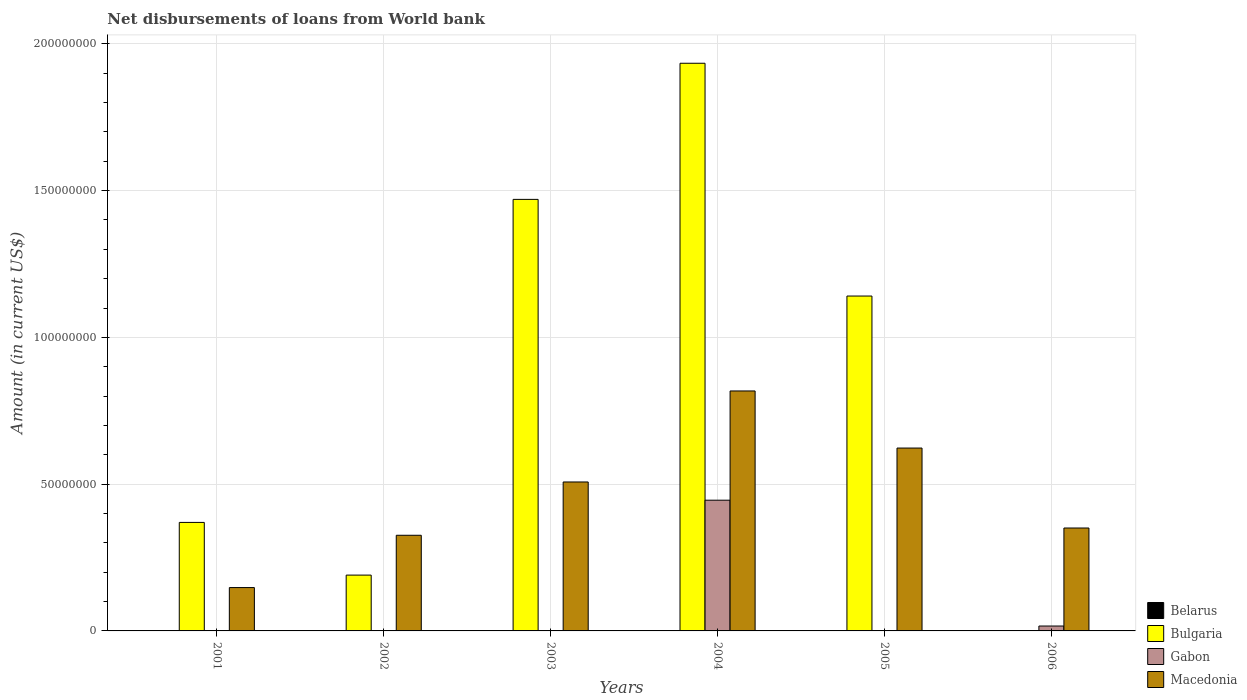How many different coloured bars are there?
Offer a very short reply. 3. How many groups of bars are there?
Your answer should be very brief. 6. Are the number of bars per tick equal to the number of legend labels?
Provide a succinct answer. No. How many bars are there on the 1st tick from the right?
Offer a terse response. 2. What is the label of the 2nd group of bars from the left?
Your answer should be very brief. 2002. In how many cases, is the number of bars for a given year not equal to the number of legend labels?
Offer a terse response. 6. What is the amount of loan disbursed from World Bank in Gabon in 2001?
Your answer should be compact. 0. Across all years, what is the maximum amount of loan disbursed from World Bank in Macedonia?
Provide a short and direct response. 8.18e+07. In which year was the amount of loan disbursed from World Bank in Macedonia maximum?
Offer a terse response. 2004. What is the total amount of loan disbursed from World Bank in Macedonia in the graph?
Provide a short and direct response. 2.77e+08. What is the difference between the amount of loan disbursed from World Bank in Bulgaria in 2002 and that in 2003?
Your answer should be compact. -1.28e+08. What is the difference between the amount of loan disbursed from World Bank in Macedonia in 2003 and the amount of loan disbursed from World Bank in Belarus in 2006?
Your answer should be compact. 5.07e+07. What is the average amount of loan disbursed from World Bank in Gabon per year?
Provide a short and direct response. 7.70e+06. In the year 2004, what is the difference between the amount of loan disbursed from World Bank in Bulgaria and amount of loan disbursed from World Bank in Macedonia?
Offer a very short reply. 1.12e+08. What is the ratio of the amount of loan disbursed from World Bank in Bulgaria in 2001 to that in 2002?
Keep it short and to the point. 1.94. What is the difference between the highest and the second highest amount of loan disbursed from World Bank in Bulgaria?
Provide a succinct answer. 4.64e+07. What is the difference between the highest and the lowest amount of loan disbursed from World Bank in Macedonia?
Give a very brief answer. 6.70e+07. In how many years, is the amount of loan disbursed from World Bank in Gabon greater than the average amount of loan disbursed from World Bank in Gabon taken over all years?
Make the answer very short. 1. Is it the case that in every year, the sum of the amount of loan disbursed from World Bank in Gabon and amount of loan disbursed from World Bank in Belarus is greater than the amount of loan disbursed from World Bank in Macedonia?
Offer a terse response. No. How many years are there in the graph?
Give a very brief answer. 6. Does the graph contain any zero values?
Your answer should be compact. Yes. Does the graph contain grids?
Offer a terse response. Yes. How are the legend labels stacked?
Your answer should be compact. Vertical. What is the title of the graph?
Provide a succinct answer. Net disbursements of loans from World bank. What is the Amount (in current US$) in Bulgaria in 2001?
Offer a terse response. 3.70e+07. What is the Amount (in current US$) of Macedonia in 2001?
Offer a terse response. 1.48e+07. What is the Amount (in current US$) of Belarus in 2002?
Your response must be concise. 0. What is the Amount (in current US$) in Bulgaria in 2002?
Your response must be concise. 1.90e+07. What is the Amount (in current US$) of Gabon in 2002?
Give a very brief answer. 0. What is the Amount (in current US$) in Macedonia in 2002?
Provide a succinct answer. 3.26e+07. What is the Amount (in current US$) in Bulgaria in 2003?
Provide a short and direct response. 1.47e+08. What is the Amount (in current US$) of Gabon in 2003?
Offer a terse response. 0. What is the Amount (in current US$) in Macedonia in 2003?
Ensure brevity in your answer.  5.07e+07. What is the Amount (in current US$) of Bulgaria in 2004?
Your response must be concise. 1.93e+08. What is the Amount (in current US$) of Gabon in 2004?
Your answer should be very brief. 4.45e+07. What is the Amount (in current US$) of Macedonia in 2004?
Provide a short and direct response. 8.18e+07. What is the Amount (in current US$) in Bulgaria in 2005?
Offer a very short reply. 1.14e+08. What is the Amount (in current US$) of Gabon in 2005?
Keep it short and to the point. 0. What is the Amount (in current US$) of Macedonia in 2005?
Make the answer very short. 6.23e+07. What is the Amount (in current US$) of Gabon in 2006?
Ensure brevity in your answer.  1.67e+06. What is the Amount (in current US$) in Macedonia in 2006?
Your answer should be compact. 3.51e+07. Across all years, what is the maximum Amount (in current US$) in Bulgaria?
Offer a terse response. 1.93e+08. Across all years, what is the maximum Amount (in current US$) of Gabon?
Make the answer very short. 4.45e+07. Across all years, what is the maximum Amount (in current US$) in Macedonia?
Your answer should be very brief. 8.18e+07. Across all years, what is the minimum Amount (in current US$) in Bulgaria?
Make the answer very short. 0. Across all years, what is the minimum Amount (in current US$) of Macedonia?
Offer a terse response. 1.48e+07. What is the total Amount (in current US$) in Belarus in the graph?
Provide a succinct answer. 0. What is the total Amount (in current US$) in Bulgaria in the graph?
Keep it short and to the point. 5.10e+08. What is the total Amount (in current US$) of Gabon in the graph?
Your response must be concise. 4.62e+07. What is the total Amount (in current US$) of Macedonia in the graph?
Keep it short and to the point. 2.77e+08. What is the difference between the Amount (in current US$) in Bulgaria in 2001 and that in 2002?
Your answer should be compact. 1.80e+07. What is the difference between the Amount (in current US$) of Macedonia in 2001 and that in 2002?
Offer a terse response. -1.78e+07. What is the difference between the Amount (in current US$) of Bulgaria in 2001 and that in 2003?
Provide a short and direct response. -1.10e+08. What is the difference between the Amount (in current US$) in Macedonia in 2001 and that in 2003?
Provide a short and direct response. -3.60e+07. What is the difference between the Amount (in current US$) of Bulgaria in 2001 and that in 2004?
Give a very brief answer. -1.56e+08. What is the difference between the Amount (in current US$) in Macedonia in 2001 and that in 2004?
Your answer should be compact. -6.70e+07. What is the difference between the Amount (in current US$) of Bulgaria in 2001 and that in 2005?
Provide a succinct answer. -7.71e+07. What is the difference between the Amount (in current US$) of Macedonia in 2001 and that in 2005?
Ensure brevity in your answer.  -4.75e+07. What is the difference between the Amount (in current US$) of Macedonia in 2001 and that in 2006?
Ensure brevity in your answer.  -2.03e+07. What is the difference between the Amount (in current US$) in Bulgaria in 2002 and that in 2003?
Offer a very short reply. -1.28e+08. What is the difference between the Amount (in current US$) of Macedonia in 2002 and that in 2003?
Your response must be concise. -1.82e+07. What is the difference between the Amount (in current US$) in Bulgaria in 2002 and that in 2004?
Give a very brief answer. -1.74e+08. What is the difference between the Amount (in current US$) of Macedonia in 2002 and that in 2004?
Offer a terse response. -4.92e+07. What is the difference between the Amount (in current US$) in Bulgaria in 2002 and that in 2005?
Keep it short and to the point. -9.51e+07. What is the difference between the Amount (in current US$) in Macedonia in 2002 and that in 2005?
Give a very brief answer. -2.97e+07. What is the difference between the Amount (in current US$) of Macedonia in 2002 and that in 2006?
Provide a short and direct response. -2.47e+06. What is the difference between the Amount (in current US$) of Bulgaria in 2003 and that in 2004?
Your answer should be very brief. -4.64e+07. What is the difference between the Amount (in current US$) of Macedonia in 2003 and that in 2004?
Provide a short and direct response. -3.10e+07. What is the difference between the Amount (in current US$) in Bulgaria in 2003 and that in 2005?
Your answer should be compact. 3.29e+07. What is the difference between the Amount (in current US$) of Macedonia in 2003 and that in 2005?
Your response must be concise. -1.16e+07. What is the difference between the Amount (in current US$) in Macedonia in 2003 and that in 2006?
Keep it short and to the point. 1.57e+07. What is the difference between the Amount (in current US$) in Bulgaria in 2004 and that in 2005?
Give a very brief answer. 7.93e+07. What is the difference between the Amount (in current US$) in Macedonia in 2004 and that in 2005?
Offer a terse response. 1.94e+07. What is the difference between the Amount (in current US$) in Gabon in 2004 and that in 2006?
Make the answer very short. 4.29e+07. What is the difference between the Amount (in current US$) of Macedonia in 2004 and that in 2006?
Offer a terse response. 4.67e+07. What is the difference between the Amount (in current US$) in Macedonia in 2005 and that in 2006?
Make the answer very short. 2.72e+07. What is the difference between the Amount (in current US$) of Bulgaria in 2001 and the Amount (in current US$) of Macedonia in 2002?
Offer a terse response. 4.38e+06. What is the difference between the Amount (in current US$) in Bulgaria in 2001 and the Amount (in current US$) in Macedonia in 2003?
Offer a terse response. -1.38e+07. What is the difference between the Amount (in current US$) of Bulgaria in 2001 and the Amount (in current US$) of Gabon in 2004?
Keep it short and to the point. -7.57e+06. What is the difference between the Amount (in current US$) of Bulgaria in 2001 and the Amount (in current US$) of Macedonia in 2004?
Your response must be concise. -4.48e+07. What is the difference between the Amount (in current US$) in Bulgaria in 2001 and the Amount (in current US$) in Macedonia in 2005?
Provide a succinct answer. -2.53e+07. What is the difference between the Amount (in current US$) in Bulgaria in 2001 and the Amount (in current US$) in Gabon in 2006?
Your answer should be very brief. 3.53e+07. What is the difference between the Amount (in current US$) in Bulgaria in 2001 and the Amount (in current US$) in Macedonia in 2006?
Ensure brevity in your answer.  1.91e+06. What is the difference between the Amount (in current US$) in Bulgaria in 2002 and the Amount (in current US$) in Macedonia in 2003?
Offer a terse response. -3.17e+07. What is the difference between the Amount (in current US$) of Bulgaria in 2002 and the Amount (in current US$) of Gabon in 2004?
Give a very brief answer. -2.55e+07. What is the difference between the Amount (in current US$) in Bulgaria in 2002 and the Amount (in current US$) in Macedonia in 2004?
Offer a very short reply. -6.27e+07. What is the difference between the Amount (in current US$) of Bulgaria in 2002 and the Amount (in current US$) of Macedonia in 2005?
Ensure brevity in your answer.  -4.33e+07. What is the difference between the Amount (in current US$) of Bulgaria in 2002 and the Amount (in current US$) of Gabon in 2006?
Your answer should be compact. 1.73e+07. What is the difference between the Amount (in current US$) in Bulgaria in 2002 and the Amount (in current US$) in Macedonia in 2006?
Your answer should be very brief. -1.60e+07. What is the difference between the Amount (in current US$) of Bulgaria in 2003 and the Amount (in current US$) of Gabon in 2004?
Your response must be concise. 1.02e+08. What is the difference between the Amount (in current US$) of Bulgaria in 2003 and the Amount (in current US$) of Macedonia in 2004?
Your answer should be compact. 6.53e+07. What is the difference between the Amount (in current US$) of Bulgaria in 2003 and the Amount (in current US$) of Macedonia in 2005?
Your response must be concise. 8.47e+07. What is the difference between the Amount (in current US$) in Bulgaria in 2003 and the Amount (in current US$) in Gabon in 2006?
Make the answer very short. 1.45e+08. What is the difference between the Amount (in current US$) in Bulgaria in 2003 and the Amount (in current US$) in Macedonia in 2006?
Offer a very short reply. 1.12e+08. What is the difference between the Amount (in current US$) of Bulgaria in 2004 and the Amount (in current US$) of Macedonia in 2005?
Your response must be concise. 1.31e+08. What is the difference between the Amount (in current US$) of Gabon in 2004 and the Amount (in current US$) of Macedonia in 2005?
Offer a very short reply. -1.78e+07. What is the difference between the Amount (in current US$) of Bulgaria in 2004 and the Amount (in current US$) of Gabon in 2006?
Offer a terse response. 1.92e+08. What is the difference between the Amount (in current US$) of Bulgaria in 2004 and the Amount (in current US$) of Macedonia in 2006?
Your response must be concise. 1.58e+08. What is the difference between the Amount (in current US$) in Gabon in 2004 and the Amount (in current US$) in Macedonia in 2006?
Offer a terse response. 9.48e+06. What is the difference between the Amount (in current US$) of Bulgaria in 2005 and the Amount (in current US$) of Gabon in 2006?
Your answer should be very brief. 1.12e+08. What is the difference between the Amount (in current US$) of Bulgaria in 2005 and the Amount (in current US$) of Macedonia in 2006?
Ensure brevity in your answer.  7.90e+07. What is the average Amount (in current US$) of Bulgaria per year?
Provide a short and direct response. 8.51e+07. What is the average Amount (in current US$) in Gabon per year?
Give a very brief answer. 7.70e+06. What is the average Amount (in current US$) of Macedonia per year?
Keep it short and to the point. 4.62e+07. In the year 2001, what is the difference between the Amount (in current US$) of Bulgaria and Amount (in current US$) of Macedonia?
Keep it short and to the point. 2.22e+07. In the year 2002, what is the difference between the Amount (in current US$) of Bulgaria and Amount (in current US$) of Macedonia?
Ensure brevity in your answer.  -1.36e+07. In the year 2003, what is the difference between the Amount (in current US$) of Bulgaria and Amount (in current US$) of Macedonia?
Offer a very short reply. 9.63e+07. In the year 2004, what is the difference between the Amount (in current US$) in Bulgaria and Amount (in current US$) in Gabon?
Your response must be concise. 1.49e+08. In the year 2004, what is the difference between the Amount (in current US$) of Bulgaria and Amount (in current US$) of Macedonia?
Your answer should be very brief. 1.12e+08. In the year 2004, what is the difference between the Amount (in current US$) of Gabon and Amount (in current US$) of Macedonia?
Offer a terse response. -3.72e+07. In the year 2005, what is the difference between the Amount (in current US$) in Bulgaria and Amount (in current US$) in Macedonia?
Ensure brevity in your answer.  5.18e+07. In the year 2006, what is the difference between the Amount (in current US$) in Gabon and Amount (in current US$) in Macedonia?
Provide a short and direct response. -3.34e+07. What is the ratio of the Amount (in current US$) in Bulgaria in 2001 to that in 2002?
Keep it short and to the point. 1.94. What is the ratio of the Amount (in current US$) of Macedonia in 2001 to that in 2002?
Keep it short and to the point. 0.45. What is the ratio of the Amount (in current US$) of Bulgaria in 2001 to that in 2003?
Offer a very short reply. 0.25. What is the ratio of the Amount (in current US$) in Macedonia in 2001 to that in 2003?
Your response must be concise. 0.29. What is the ratio of the Amount (in current US$) in Bulgaria in 2001 to that in 2004?
Provide a short and direct response. 0.19. What is the ratio of the Amount (in current US$) in Macedonia in 2001 to that in 2004?
Your answer should be compact. 0.18. What is the ratio of the Amount (in current US$) of Bulgaria in 2001 to that in 2005?
Your answer should be compact. 0.32. What is the ratio of the Amount (in current US$) of Macedonia in 2001 to that in 2005?
Offer a very short reply. 0.24. What is the ratio of the Amount (in current US$) in Macedonia in 2001 to that in 2006?
Your answer should be very brief. 0.42. What is the ratio of the Amount (in current US$) in Bulgaria in 2002 to that in 2003?
Ensure brevity in your answer.  0.13. What is the ratio of the Amount (in current US$) in Macedonia in 2002 to that in 2003?
Make the answer very short. 0.64. What is the ratio of the Amount (in current US$) in Bulgaria in 2002 to that in 2004?
Your response must be concise. 0.1. What is the ratio of the Amount (in current US$) of Macedonia in 2002 to that in 2004?
Your response must be concise. 0.4. What is the ratio of the Amount (in current US$) of Bulgaria in 2002 to that in 2005?
Keep it short and to the point. 0.17. What is the ratio of the Amount (in current US$) in Macedonia in 2002 to that in 2005?
Your answer should be compact. 0.52. What is the ratio of the Amount (in current US$) of Macedonia in 2002 to that in 2006?
Your answer should be compact. 0.93. What is the ratio of the Amount (in current US$) in Bulgaria in 2003 to that in 2004?
Offer a very short reply. 0.76. What is the ratio of the Amount (in current US$) of Macedonia in 2003 to that in 2004?
Offer a very short reply. 0.62. What is the ratio of the Amount (in current US$) of Bulgaria in 2003 to that in 2005?
Your answer should be compact. 1.29. What is the ratio of the Amount (in current US$) of Macedonia in 2003 to that in 2005?
Ensure brevity in your answer.  0.81. What is the ratio of the Amount (in current US$) of Macedonia in 2003 to that in 2006?
Your response must be concise. 1.45. What is the ratio of the Amount (in current US$) of Bulgaria in 2004 to that in 2005?
Ensure brevity in your answer.  1.7. What is the ratio of the Amount (in current US$) of Macedonia in 2004 to that in 2005?
Offer a very short reply. 1.31. What is the ratio of the Amount (in current US$) of Gabon in 2004 to that in 2006?
Your answer should be very brief. 26.72. What is the ratio of the Amount (in current US$) of Macedonia in 2004 to that in 2006?
Provide a short and direct response. 2.33. What is the ratio of the Amount (in current US$) of Macedonia in 2005 to that in 2006?
Your answer should be compact. 1.78. What is the difference between the highest and the second highest Amount (in current US$) in Bulgaria?
Keep it short and to the point. 4.64e+07. What is the difference between the highest and the second highest Amount (in current US$) of Macedonia?
Your answer should be very brief. 1.94e+07. What is the difference between the highest and the lowest Amount (in current US$) of Bulgaria?
Offer a terse response. 1.93e+08. What is the difference between the highest and the lowest Amount (in current US$) of Gabon?
Give a very brief answer. 4.45e+07. What is the difference between the highest and the lowest Amount (in current US$) of Macedonia?
Your response must be concise. 6.70e+07. 